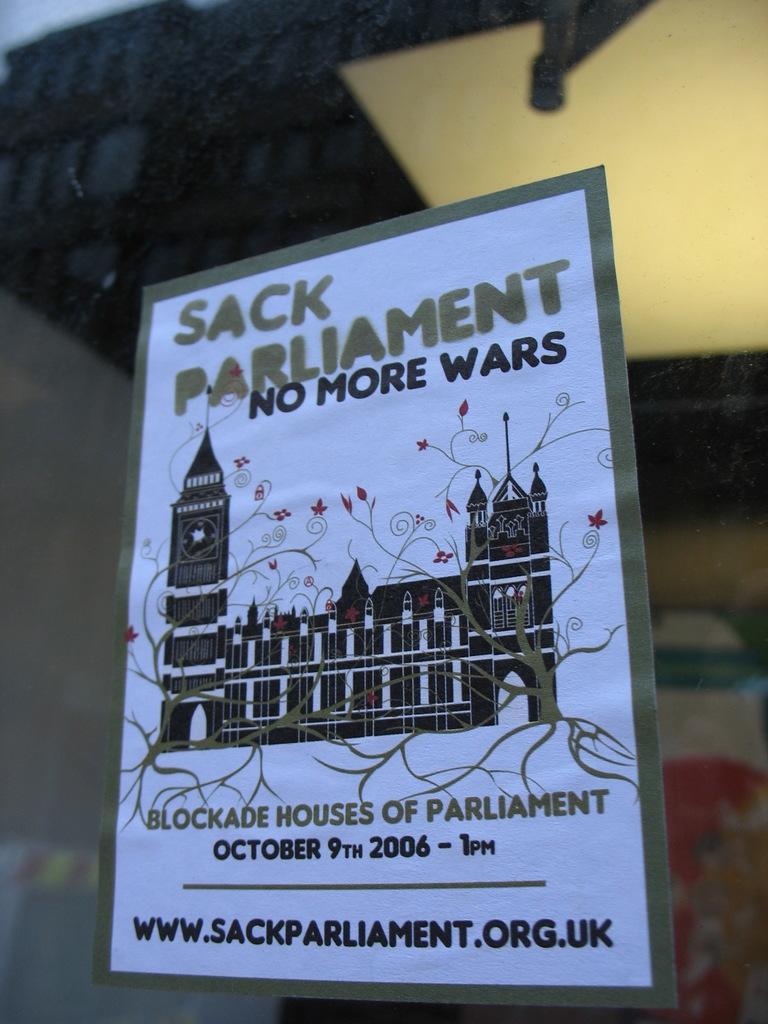What kind of event is this poster advertising?
Provide a short and direct response. Sack parliament. What day is the event?
Your response must be concise. October 9th 2006. 